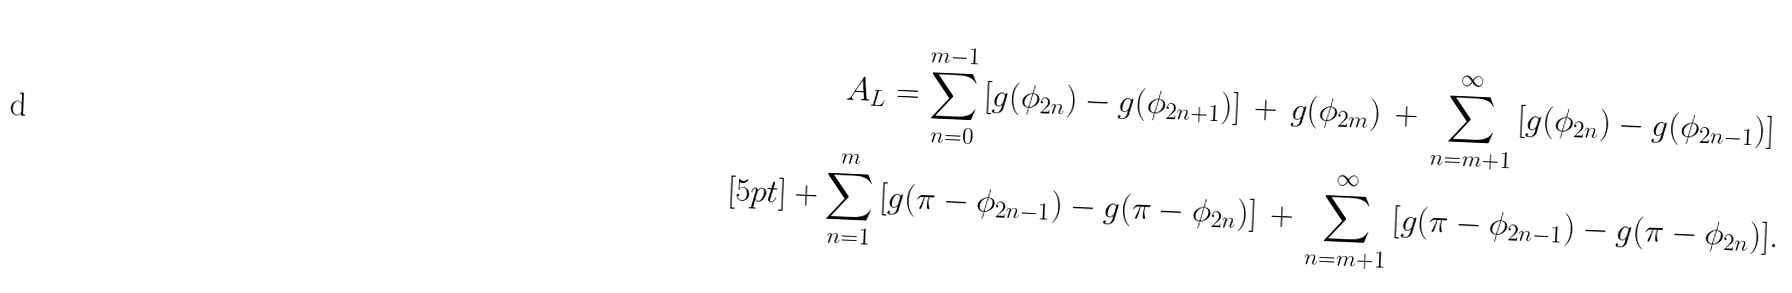<formula> <loc_0><loc_0><loc_500><loc_500>A _ { L } = \sum _ { n = 0 } ^ { m - 1 } \left [ g ( \phi _ { 2 n } ) - g ( \phi _ { 2 n + 1 } ) \right ] \, + \, g ( \phi _ { 2 m } ) \, + \, \sum _ { n = m + 1 } ^ { \infty } \left [ g ( \phi _ { 2 n } ) - g ( \phi _ { 2 n - 1 } ) \right ] & \\ [ 5 p t ] + \sum _ { n = 1 } ^ { m } \left [ g ( \pi - \phi _ { 2 n - 1 } ) - g ( \pi - \phi _ { 2 n } ) \right ] \, + \, \sum _ { n = m + 1 } ^ { \infty } \left [ g ( \pi - \phi _ { 2 n - 1 } ) - g ( \pi - \phi _ { 2 n } ) \right ] & .</formula> 